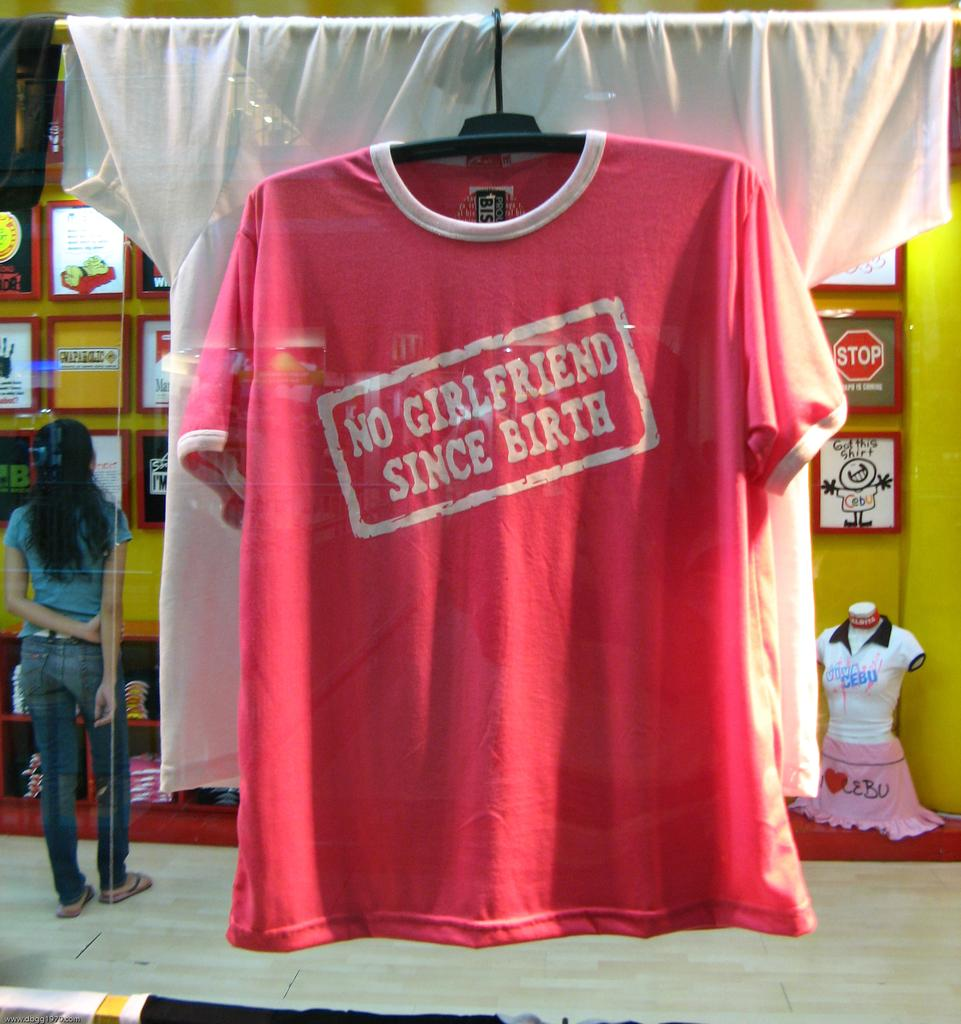<image>
Render a clear and concise summary of the photo. A picture of a shirt on a hanger talking about the wearer being single 